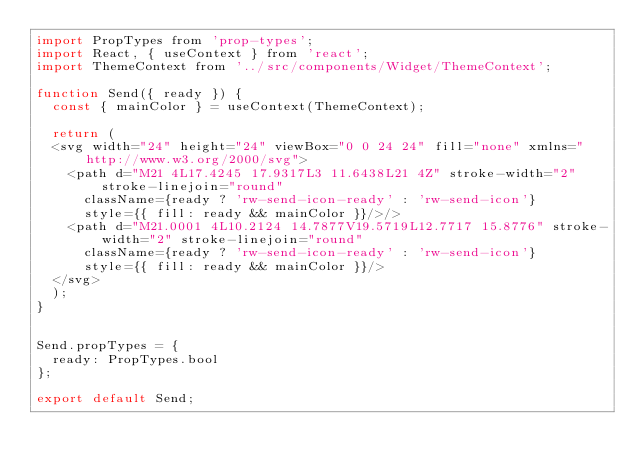Convert code to text. <code><loc_0><loc_0><loc_500><loc_500><_JavaScript_>import PropTypes from 'prop-types';
import React, { useContext } from 'react';
import ThemeContext from '../src/components/Widget/ThemeContext';

function Send({ ready }) {
  const { mainColor } = useContext(ThemeContext);

  return (
  <svg width="24" height="24" viewBox="0 0 24 24" fill="none" xmlns="http://www.w3.org/2000/svg">
    <path d="M21 4L17.4245 17.9317L3 11.6438L21 4Z" stroke-width="2" stroke-linejoin="round"
      className={ready ? 'rw-send-icon-ready' : 'rw-send-icon'}
      style={{ fill: ready && mainColor }}/>/>
    <path d="M21.0001 4L10.2124 14.7877V19.5719L12.7717 15.8776" stroke-width="2" stroke-linejoin="round"
      className={ready ? 'rw-send-icon-ready' : 'rw-send-icon'}
      style={{ fill: ready && mainColor }}/>
  </svg>
  );
}


Send.propTypes = {
  ready: PropTypes.bool
};

export default Send;
</code> 